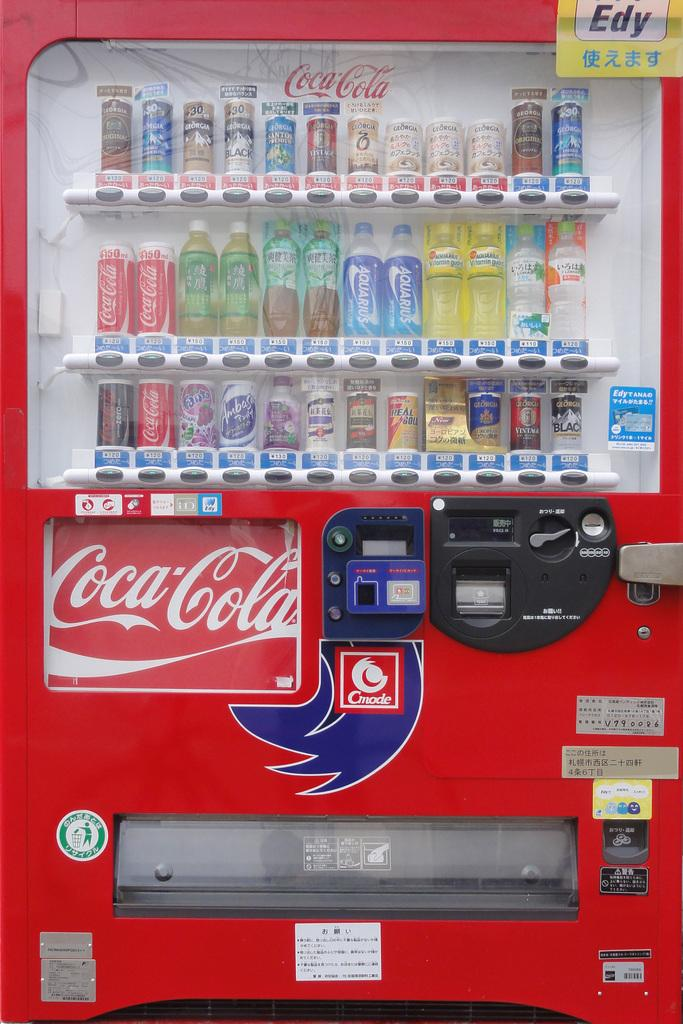<image>
Describe the image concisely. A Coca-Cola machine by Cmode offers many drinks besides Coca-Cola. 